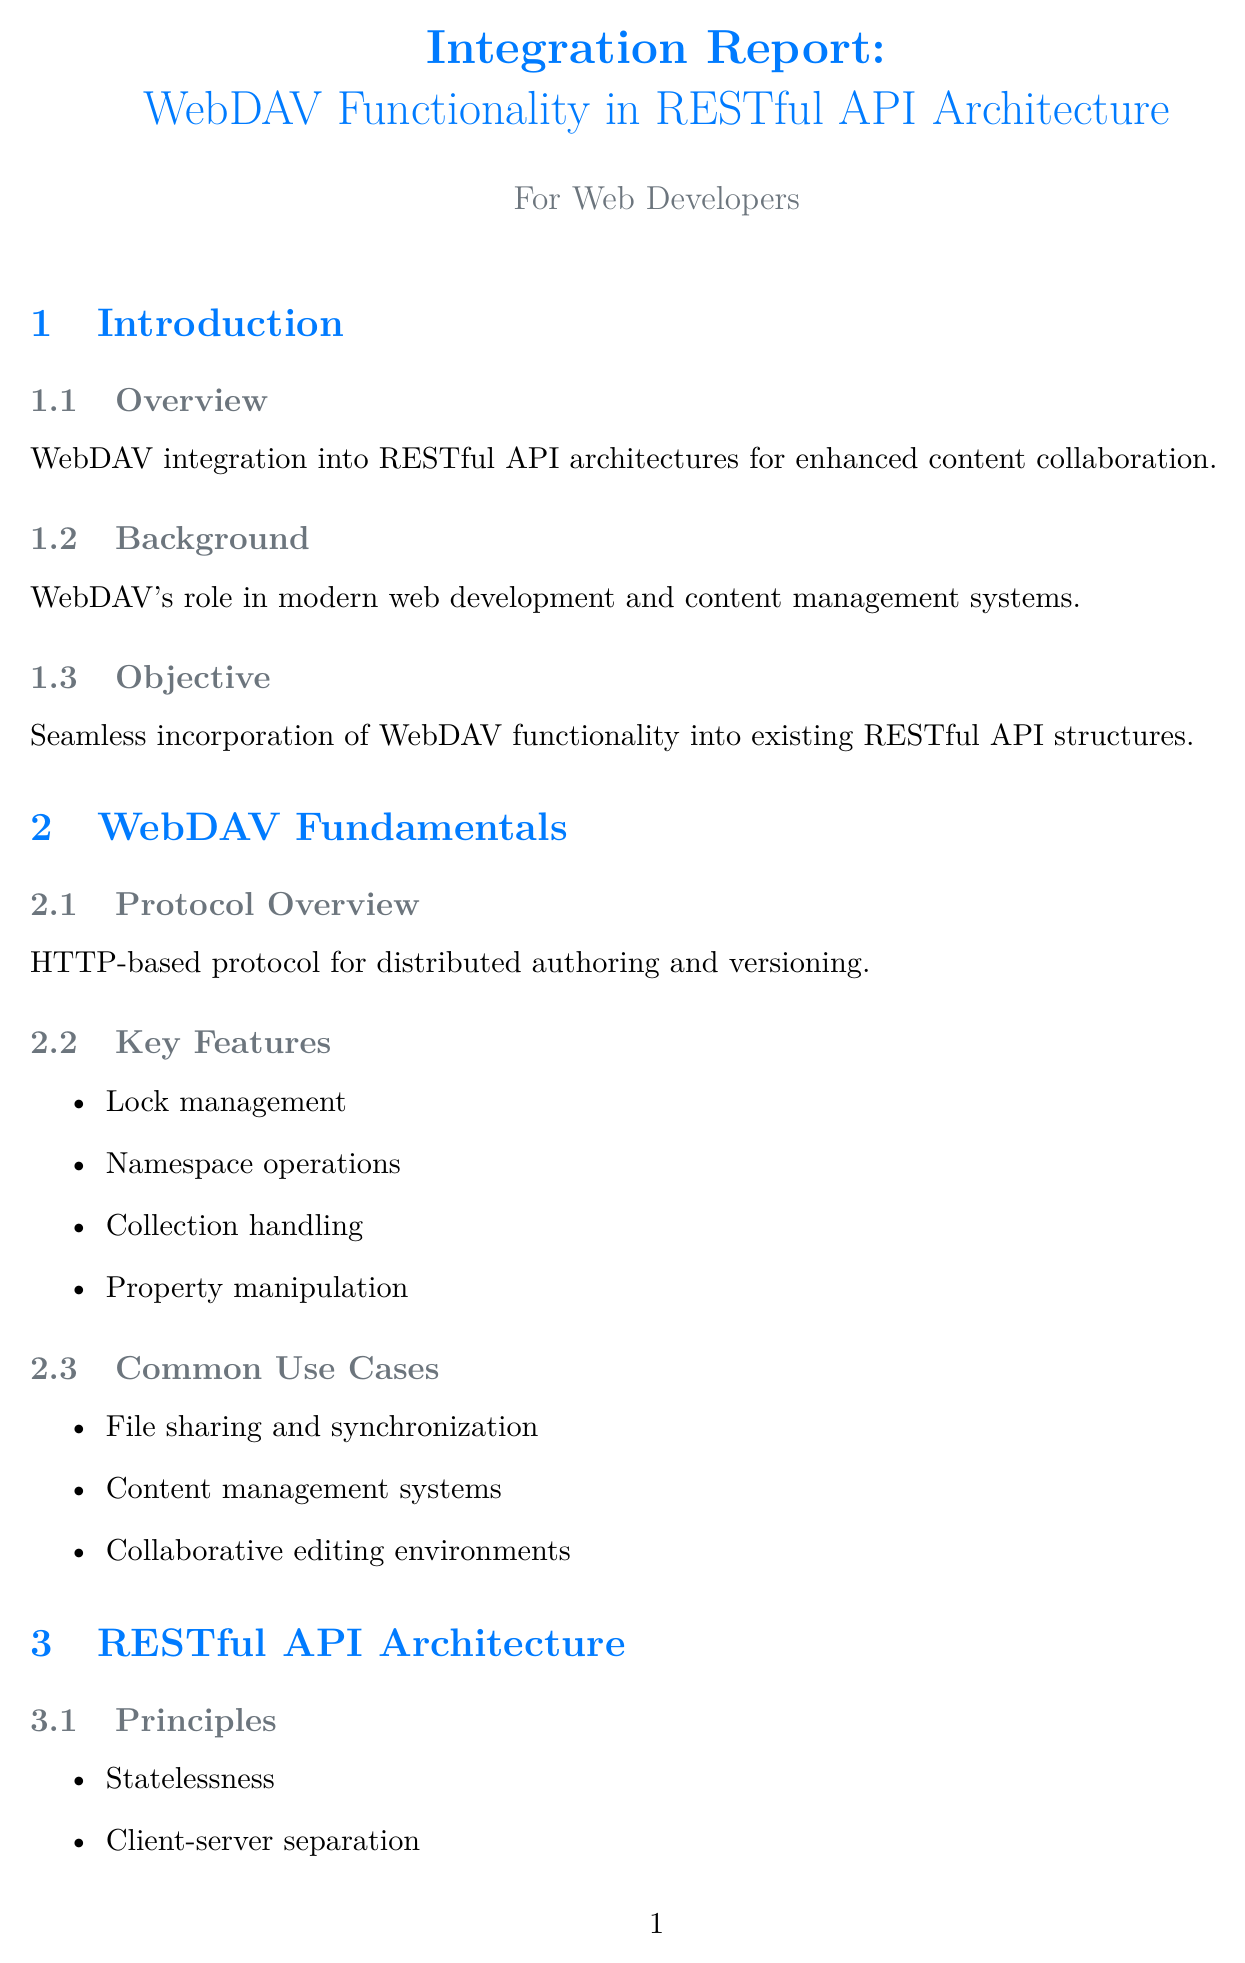What is the main objective of the report? The objective is to seamlessly incorporate WebDAV functionality into existing RESTful API structures.
Answer: Seamless incorporation of WebDAV functionality into existing RESTful API structures What is the key feature of WebDAV that involves managing edits on resources? This feature involves ensuring that resources are not edited simultaneously by multiple users.
Answer: Lock management What approach does Nextcloud use for integration? Nextcloud employs WebDAV as the core protocol with RESTful API extensions.
Answer: WebDAV as core protocol with RESTful API extensions What performance optimization strategy is mentioned in the document? This strategy focuses on improving the efficiency of data retrieval and storage operations.
Answer: Caching strategies What is the primary security concern highlighted in the report? The report emphasizes the importance of ensuring secure access to resources managed through WebDAV.
Answer: Access control What is the primary advantage of using WebDAV as a separate microservice? This approach provides a clear division of responsibilities between different services within the architecture.
Answer: Clear separation of concerns How many common use cases are listed under WebDAV fundamentals? The document outlines three common use cases for WebDAV functionality.
Answer: Three Which authentication method is mentioned as a basic option? The document lists a straightforward method for authenticating users accessing resources via WebDAV.
Answer: Basic Auth over HTTPS What is a lesson learned from Box's integration approach? This lesson reflects on the importance of reconciling older technologies with newer API designs.
Answer: Challenges in maintaining compatibility between WebDAV and modern REST APIs 